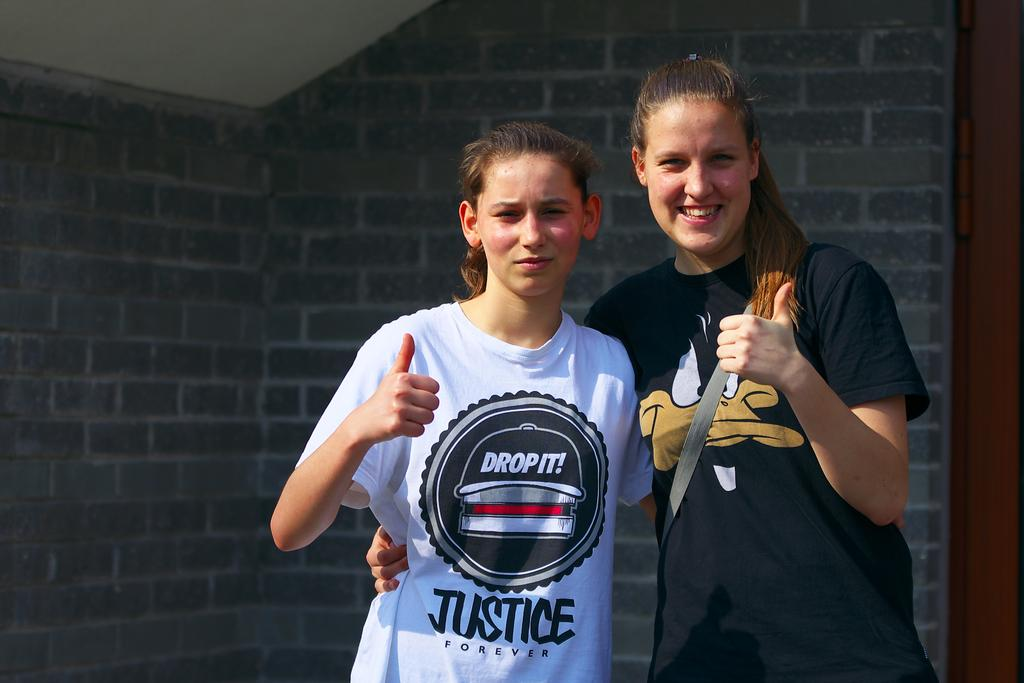<image>
Write a terse but informative summary of the picture. The tee shirt on the left says Justice Forever. 